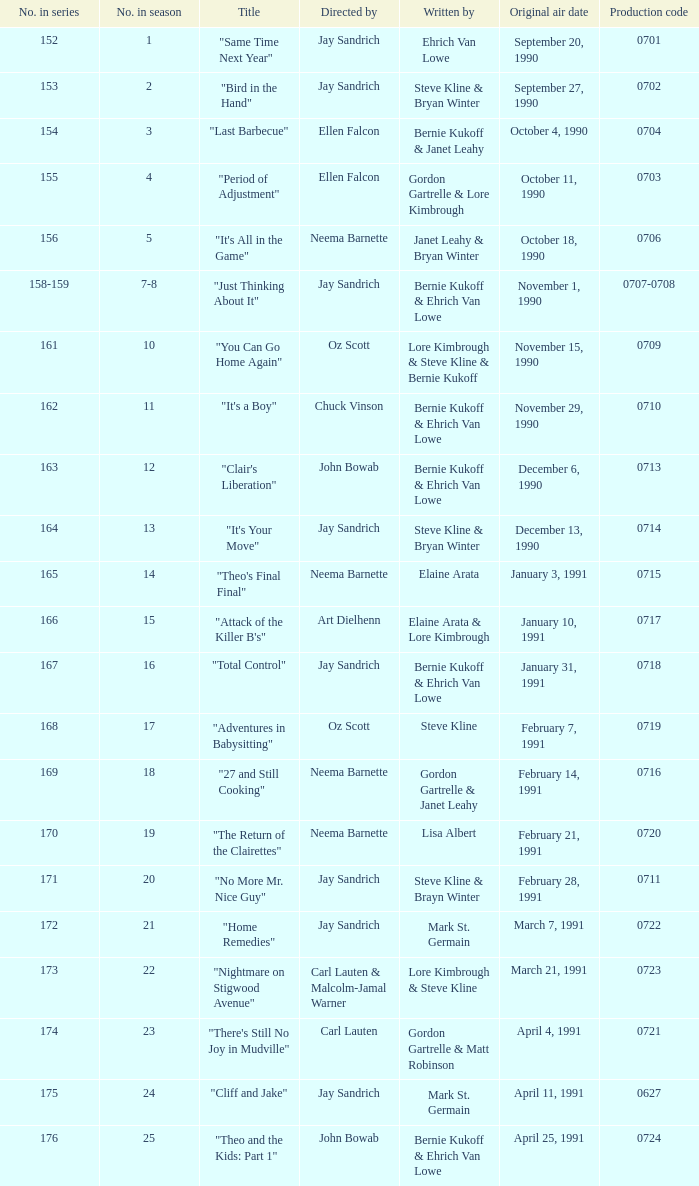The episode "adventures in babysitting" had what number in the season? 17.0. 